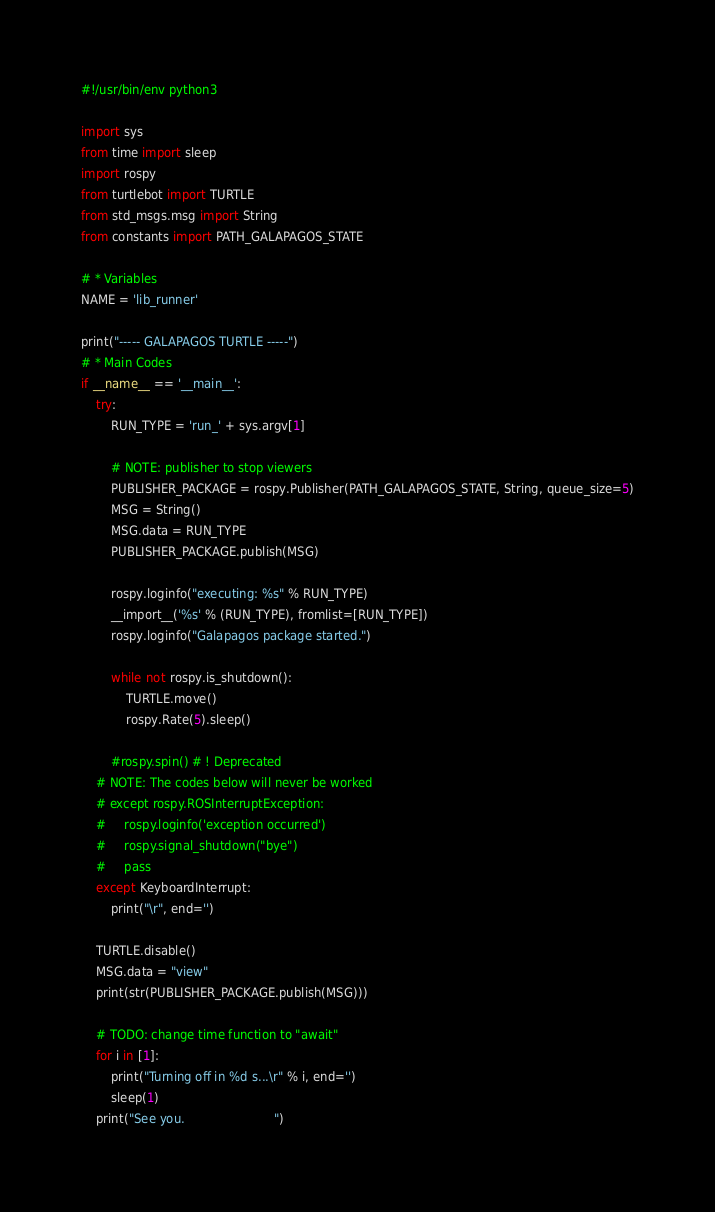<code> <loc_0><loc_0><loc_500><loc_500><_Python_>#!/usr/bin/env python3

import sys
from time import sleep
import rospy
from turtlebot import TURTLE
from std_msgs.msg import String
from constants import PATH_GALAPAGOS_STATE

# * Variables
NAME = 'lib_runner'

print("----- GALAPAGOS TURTLE -----")
# * Main Codes
if __name__ == '__main__':
    try:
        RUN_TYPE = 'run_' + sys.argv[1]

        # NOTE: publisher to stop viewers
        PUBLISHER_PACKAGE = rospy.Publisher(PATH_GALAPAGOS_STATE, String, queue_size=5)
        MSG = String()
        MSG.data = RUN_TYPE
        PUBLISHER_PACKAGE.publish(MSG)

        rospy.loginfo("executing: %s" % RUN_TYPE)
        __import__('%s' % (RUN_TYPE), fromlist=[RUN_TYPE])
        rospy.loginfo("Galapagos package started.")
        
        while not rospy.is_shutdown():
            TURTLE.move()
            rospy.Rate(5).sleep()
        
        #rospy.spin() # ! Deprecated
    # NOTE: The codes below will never be worked
    # except rospy.ROSInterruptException:
    #     rospy.loginfo('exception occurred')
    #     rospy.signal_shutdown("bye")
    #     pass
    except KeyboardInterrupt:
        print("\r", end='')

    TURTLE.disable()
    MSG.data = "view"
    print(str(PUBLISHER_PACKAGE.publish(MSG)))
    
    # TODO: change time function to "await"
    for i in [1]:
        print("Turning off in %d s...\r" % i, end='')
        sleep(1)
    print("See you.                        ")
</code> 